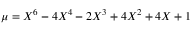Convert formula to latex. <formula><loc_0><loc_0><loc_500><loc_500>\mu = X ^ { 6 } - 4 X ^ { 4 } - 2 X ^ { 3 } + 4 X ^ { 2 } + 4 X + 1</formula> 